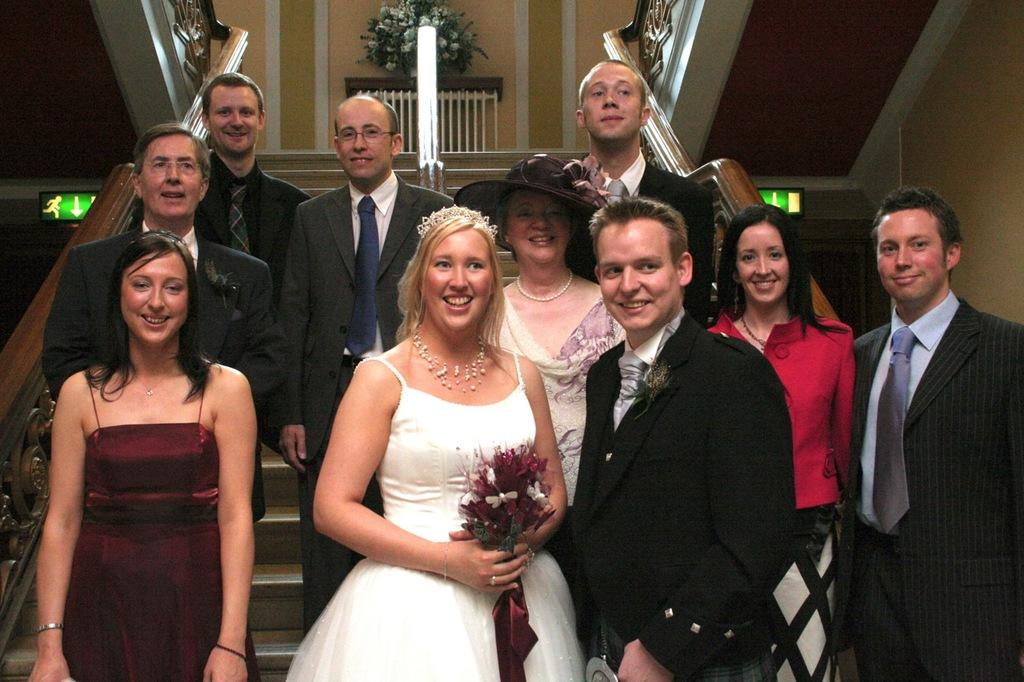What are the people in the image doing? The group of people is standing on the steps. What can be seen in the background of the image? There is a flower vase in the background. What is present on either side of the staircase? There are sign boards on either side of the staircase. What type of property is being sold in the image? There is no indication of a property being sold in the image; it primarily features a group of people standing on the steps. 